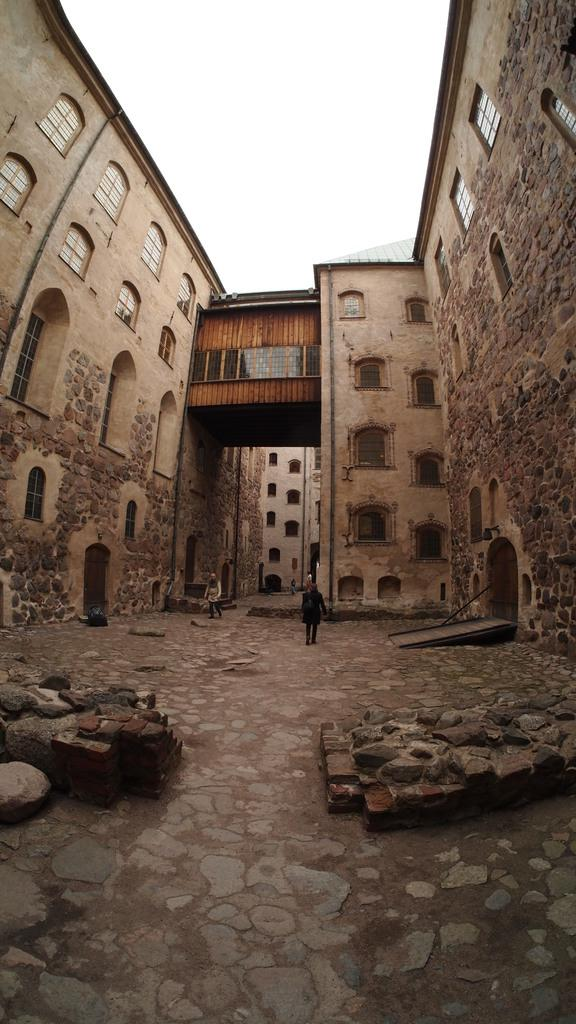What type of natural elements can be seen in the image? There are rocks in the image. What type of structures are present in the image? There are buildings with windows in the image. How many people are visible in the image? There are two persons standing in the image. What is visible in the background of the image? The sky is visible in the background of the image. How many eggs can be seen in the image? There are no eggs present in the image. What type of bird is perched on the rocks in the image? There is no bird present in the image; it only features rocks and buildings. 